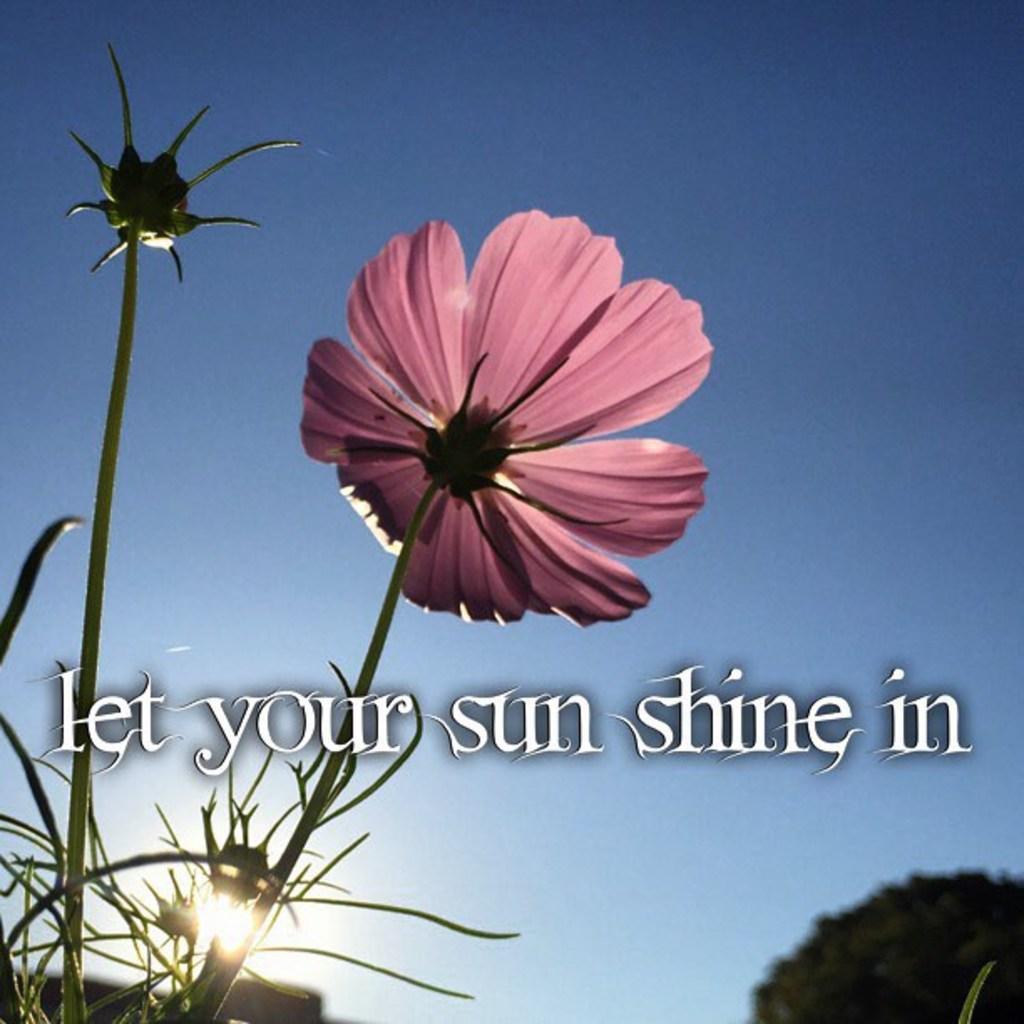Could you give a brief overview of what you see in this image? In this image I can see a flower in pink color. Background I can see trees in green color, the sky is in blue color and I can see something written on the image. 